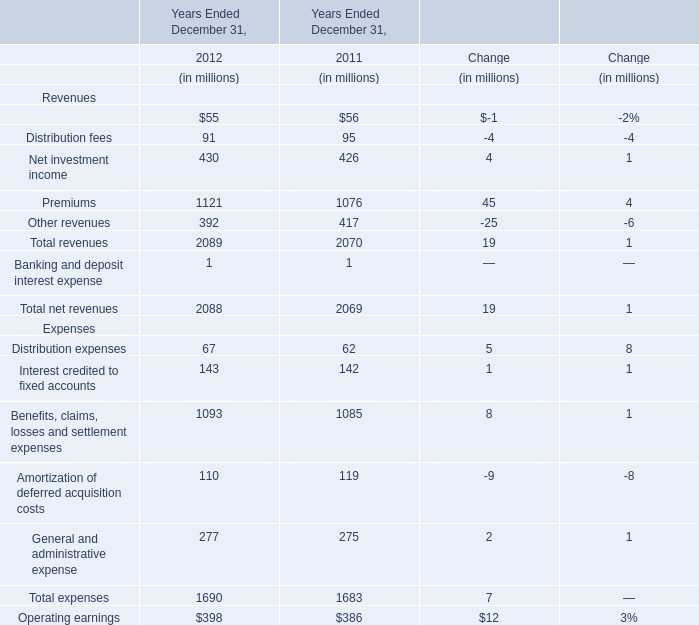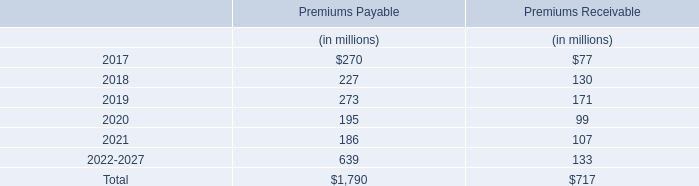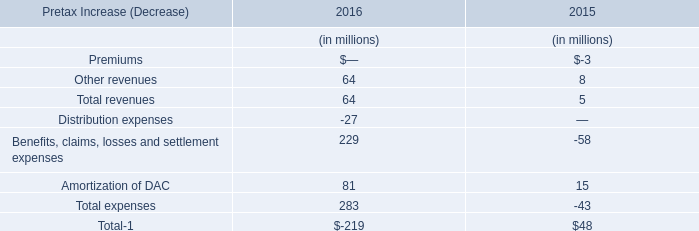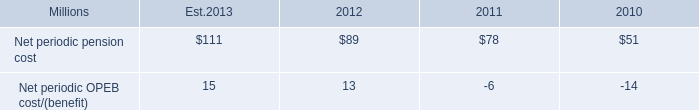what is the estimated growth rate in net periodic pension cost from 2011 to 2012? 
Computations: ((89 - 78) / 78)
Answer: 0.14103. 